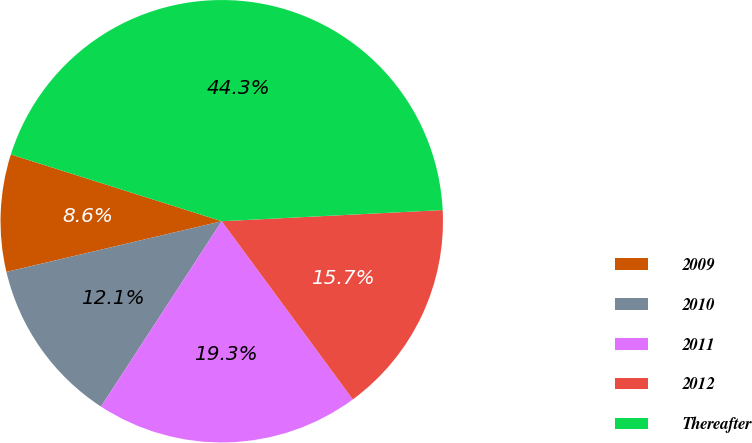Convert chart to OTSL. <chart><loc_0><loc_0><loc_500><loc_500><pie_chart><fcel>2009<fcel>2010<fcel>2011<fcel>2012<fcel>Thereafter<nl><fcel>8.56%<fcel>12.13%<fcel>19.28%<fcel>15.71%<fcel>44.31%<nl></chart> 